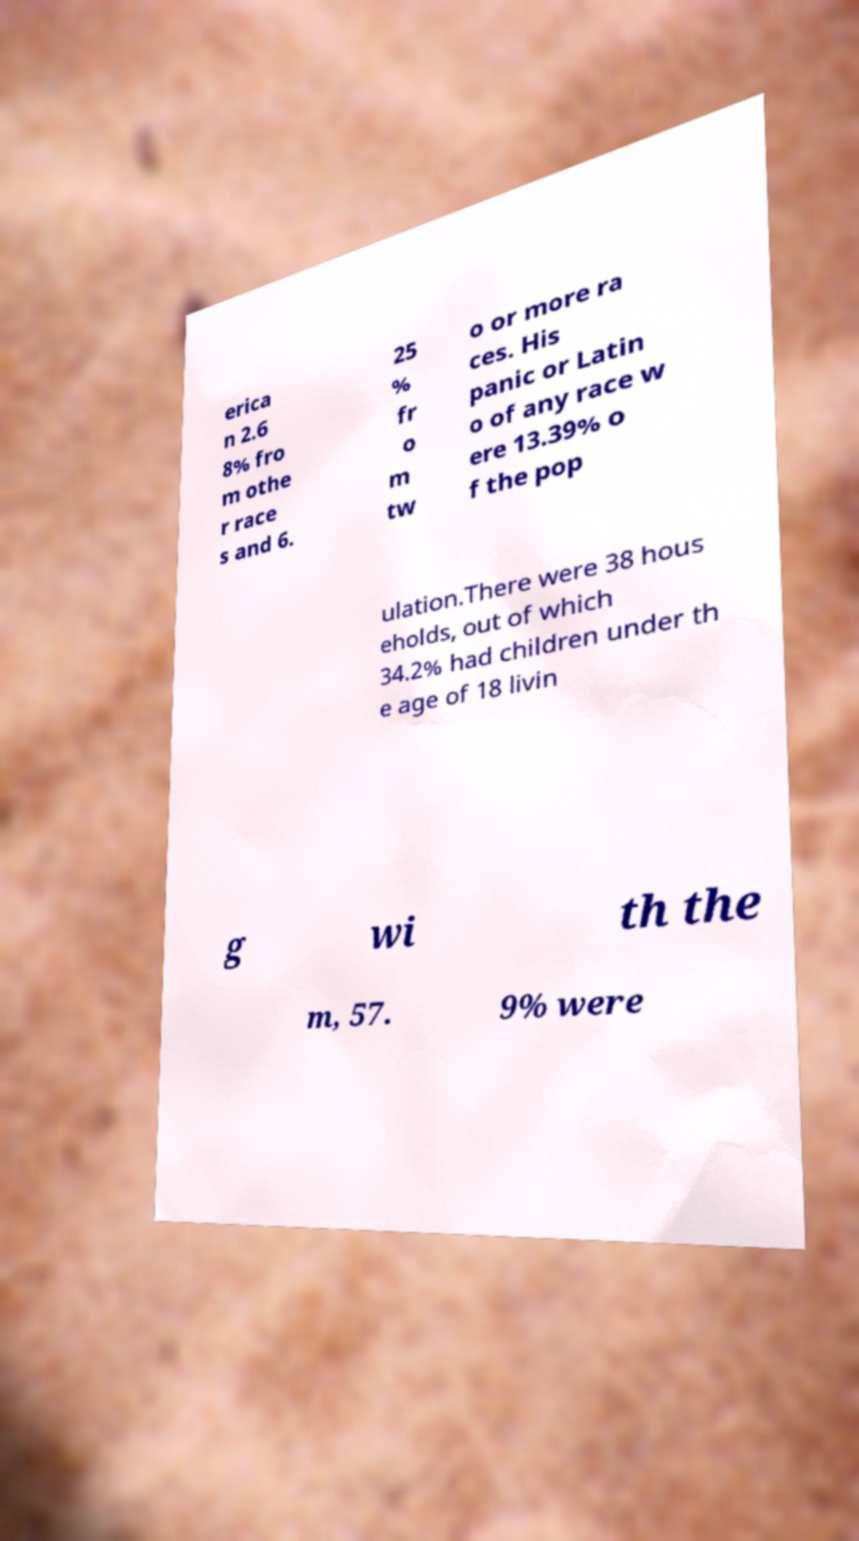What messages or text are displayed in this image? I need them in a readable, typed format. erica n 2.6 8% fro m othe r race s and 6. 25 % fr o m tw o or more ra ces. His panic or Latin o of any race w ere 13.39% o f the pop ulation.There were 38 hous eholds, out of which 34.2% had children under th e age of 18 livin g wi th the m, 57. 9% were 